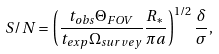Convert formula to latex. <formula><loc_0><loc_0><loc_500><loc_500>S / N = \left ( \frac { t _ { o b s } \Theta _ { F O V } } { t _ { e x p } \Omega _ { s u r v e y } } \frac { R _ { * } } { \pi a } \right ) ^ { 1 / 2 } \frac { \delta } { \sigma } ,</formula> 